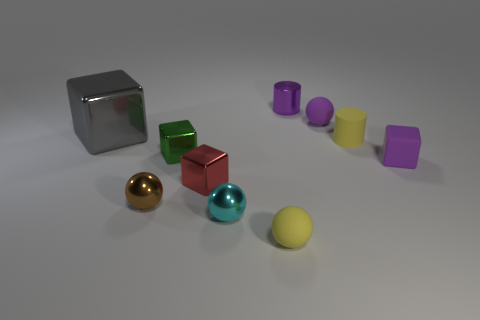Subtract all tiny cyan metallic balls. How many balls are left? 3 Subtract 1 cylinders. How many cylinders are left? 1 Subtract all purple cylinders. How many cylinders are left? 1 Subtract 0 green cylinders. How many objects are left? 10 Subtract all cubes. How many objects are left? 6 Subtract all green cylinders. Subtract all blue spheres. How many cylinders are left? 2 Subtract all gray cubes. How many purple cylinders are left? 1 Subtract all purple metallic cylinders. Subtract all yellow rubber cylinders. How many objects are left? 8 Add 9 tiny cyan things. How many tiny cyan things are left? 10 Add 2 small gray objects. How many small gray objects exist? 2 